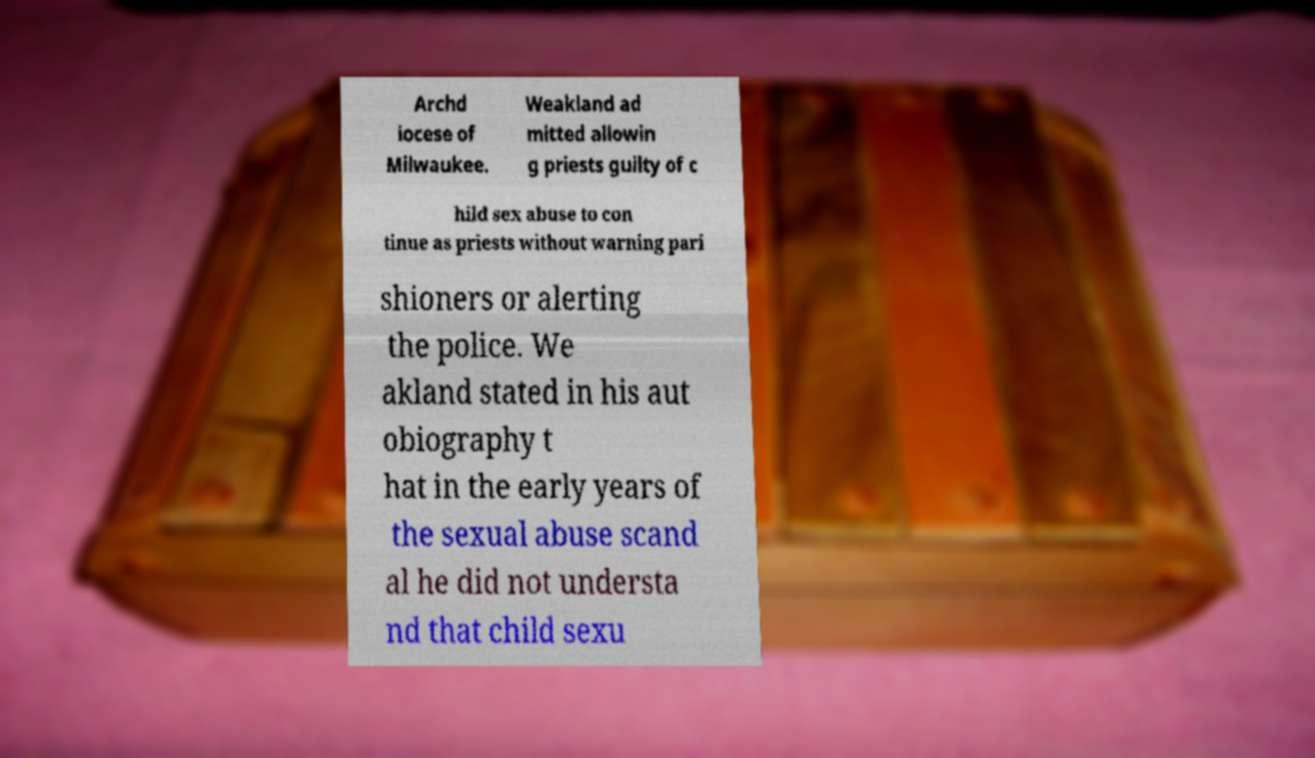Could you assist in decoding the text presented in this image and type it out clearly? Archd iocese of Milwaukee. Weakland ad mitted allowin g priests guilty of c hild sex abuse to con tinue as priests without warning pari shioners or alerting the police. We akland stated in his aut obiography t hat in the early years of the sexual abuse scand al he did not understa nd that child sexu 